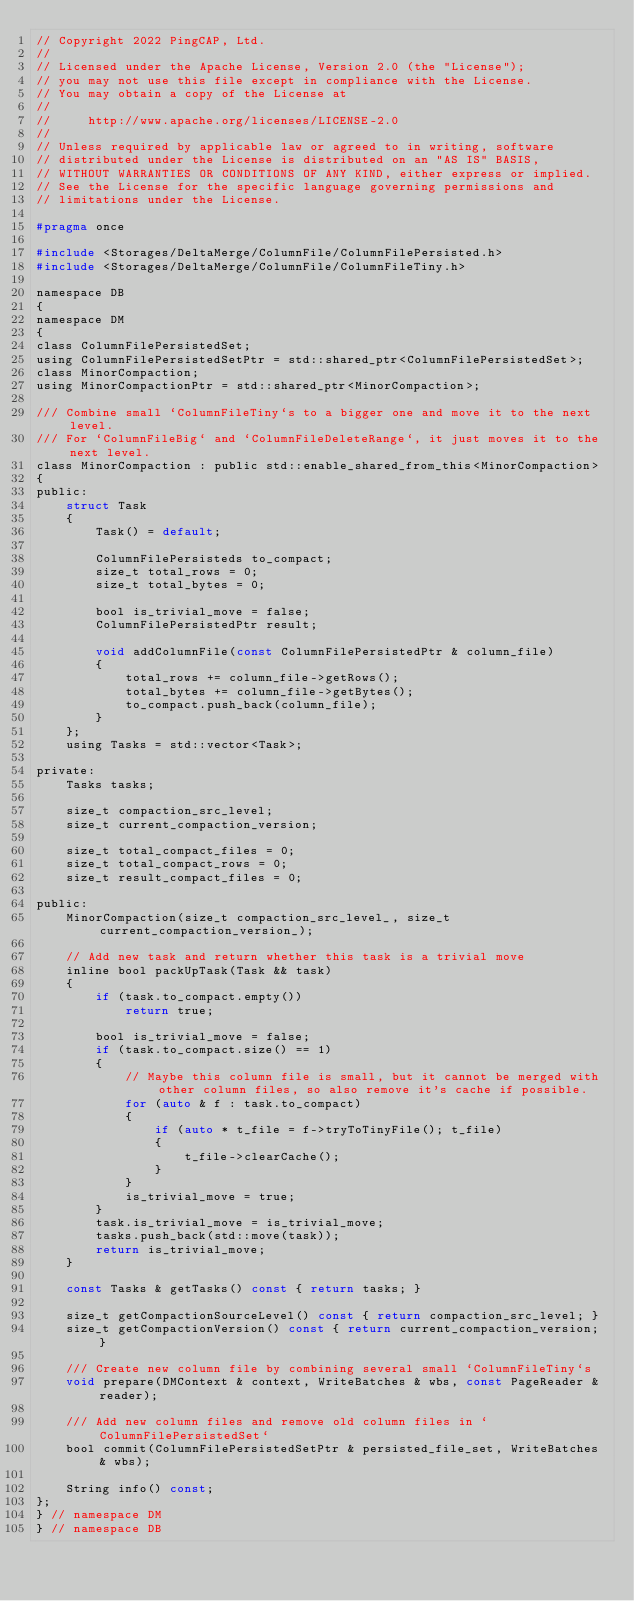Convert code to text. <code><loc_0><loc_0><loc_500><loc_500><_C_>// Copyright 2022 PingCAP, Ltd.
//
// Licensed under the Apache License, Version 2.0 (the "License");
// you may not use this file except in compliance with the License.
// You may obtain a copy of the License at
//
//     http://www.apache.org/licenses/LICENSE-2.0
//
// Unless required by applicable law or agreed to in writing, software
// distributed under the License is distributed on an "AS IS" BASIS,
// WITHOUT WARRANTIES OR CONDITIONS OF ANY KIND, either express or implied.
// See the License for the specific language governing permissions and
// limitations under the License.

#pragma once

#include <Storages/DeltaMerge/ColumnFile/ColumnFilePersisted.h>
#include <Storages/DeltaMerge/ColumnFile/ColumnFileTiny.h>

namespace DB
{
namespace DM
{
class ColumnFilePersistedSet;
using ColumnFilePersistedSetPtr = std::shared_ptr<ColumnFilePersistedSet>;
class MinorCompaction;
using MinorCompactionPtr = std::shared_ptr<MinorCompaction>;

/// Combine small `ColumnFileTiny`s to a bigger one and move it to the next level.
/// For `ColumnFileBig` and `ColumnFileDeleteRange`, it just moves it to the next level.
class MinorCompaction : public std::enable_shared_from_this<MinorCompaction>
{
public:
    struct Task
    {
        Task() = default;

        ColumnFilePersisteds to_compact;
        size_t total_rows = 0;
        size_t total_bytes = 0;

        bool is_trivial_move = false;
        ColumnFilePersistedPtr result;

        void addColumnFile(const ColumnFilePersistedPtr & column_file)
        {
            total_rows += column_file->getRows();
            total_bytes += column_file->getBytes();
            to_compact.push_back(column_file);
        }
    };
    using Tasks = std::vector<Task>;

private:
    Tasks tasks;

    size_t compaction_src_level;
    size_t current_compaction_version;

    size_t total_compact_files = 0;
    size_t total_compact_rows = 0;
    size_t result_compact_files = 0;

public:
    MinorCompaction(size_t compaction_src_level_, size_t current_compaction_version_);

    // Add new task and return whether this task is a trivial move
    inline bool packUpTask(Task && task)
    {
        if (task.to_compact.empty())
            return true;

        bool is_trivial_move = false;
        if (task.to_compact.size() == 1)
        {
            // Maybe this column file is small, but it cannot be merged with other column files, so also remove it's cache if possible.
            for (auto & f : task.to_compact)
            {
                if (auto * t_file = f->tryToTinyFile(); t_file)
                {
                    t_file->clearCache();
                }
            }
            is_trivial_move = true;
        }
        task.is_trivial_move = is_trivial_move;
        tasks.push_back(std::move(task));
        return is_trivial_move;
    }

    const Tasks & getTasks() const { return tasks; }

    size_t getCompactionSourceLevel() const { return compaction_src_level; }
    size_t getCompactionVersion() const { return current_compaction_version; }

    /// Create new column file by combining several small `ColumnFileTiny`s
    void prepare(DMContext & context, WriteBatches & wbs, const PageReader & reader);

    /// Add new column files and remove old column files in `ColumnFilePersistedSet`
    bool commit(ColumnFilePersistedSetPtr & persisted_file_set, WriteBatches & wbs);

    String info() const;
};
} // namespace DM
} // namespace DB
</code> 